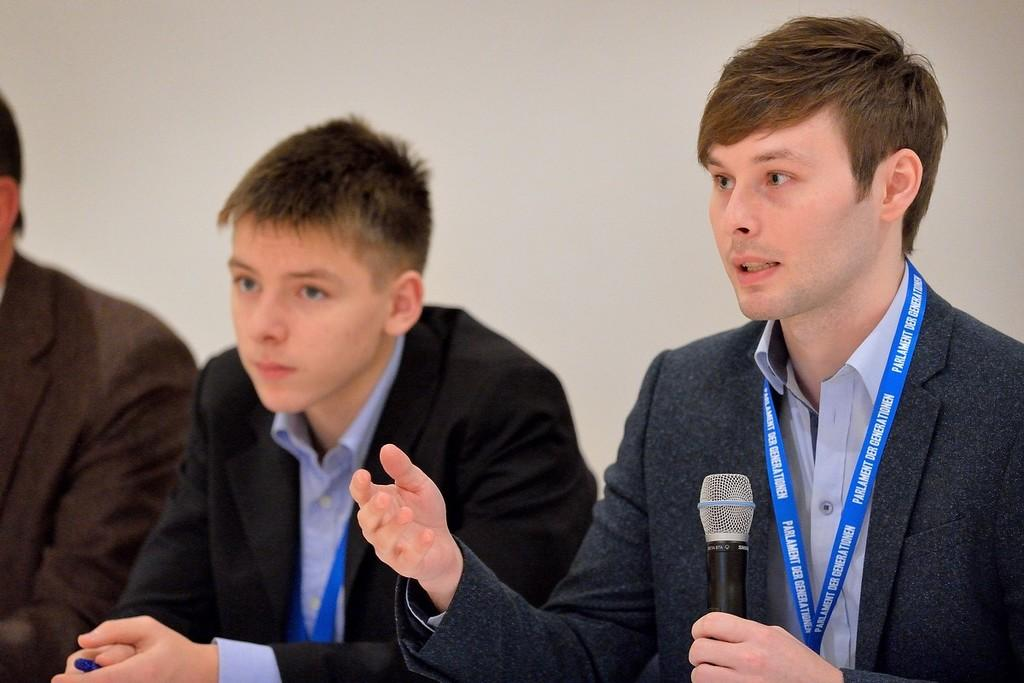How many people are in the image? There are three persons in the image. What is one of the persons holding in his hand? One of the persons is holding a microphone in his hand. What color is the crow that is perched on the microphone in the image? There is no crow present in the image; only three persons and a microphone are visible. 